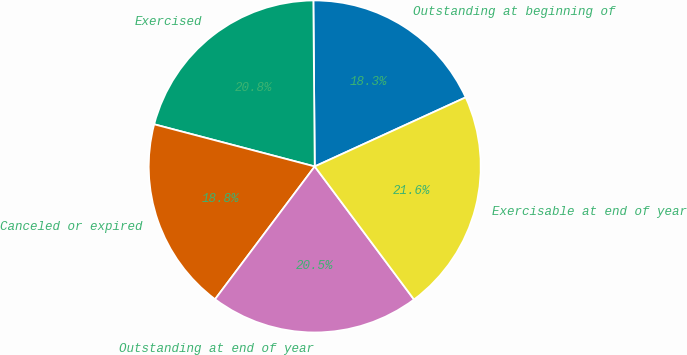<chart> <loc_0><loc_0><loc_500><loc_500><pie_chart><fcel>Outstanding at beginning of<fcel>Exercised<fcel>Canceled or expired<fcel>Outstanding at end of year<fcel>Exercisable at end of year<nl><fcel>18.3%<fcel>20.78%<fcel>18.84%<fcel>20.45%<fcel>21.63%<nl></chart> 